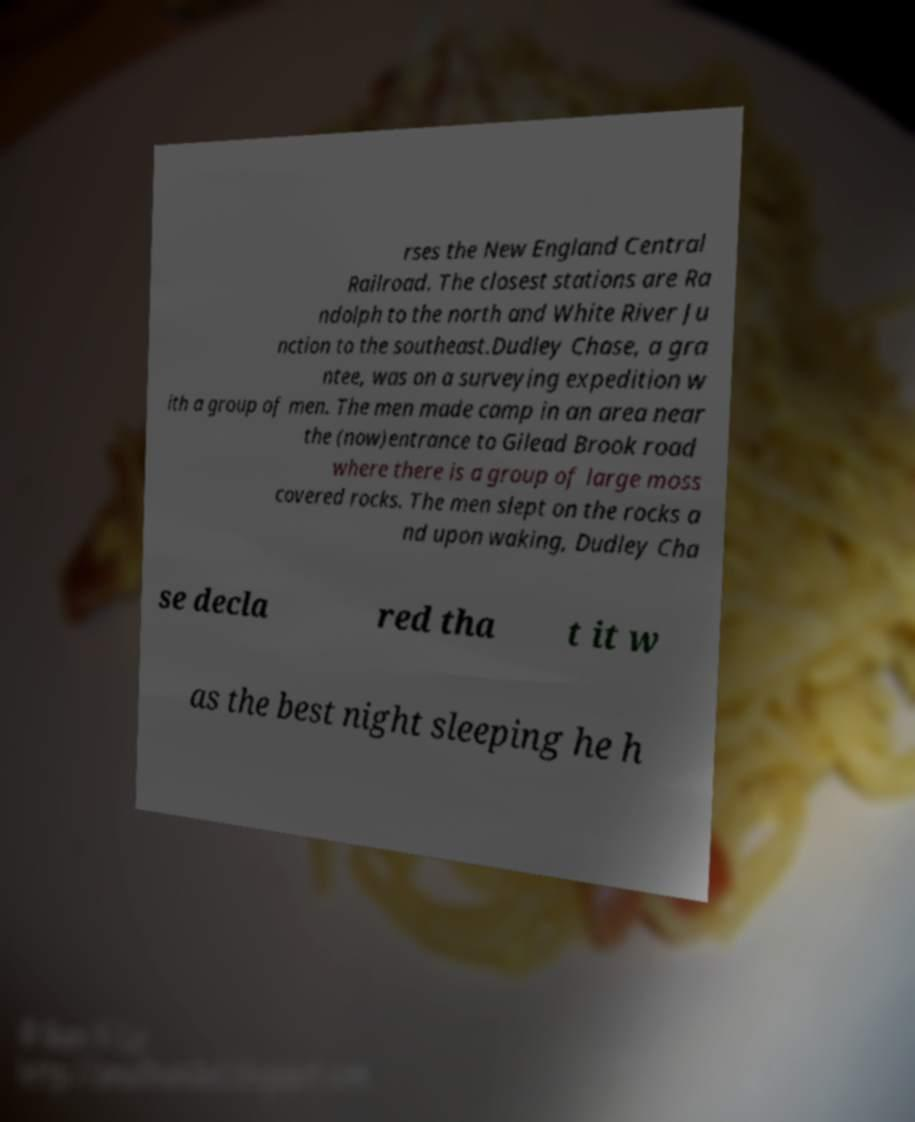Can you accurately transcribe the text from the provided image for me? rses the New England Central Railroad. The closest stations are Ra ndolph to the north and White River Ju nction to the southeast.Dudley Chase, a gra ntee, was on a surveying expedition w ith a group of men. The men made camp in an area near the (now)entrance to Gilead Brook road where there is a group of large moss covered rocks. The men slept on the rocks a nd upon waking, Dudley Cha se decla red tha t it w as the best night sleeping he h 